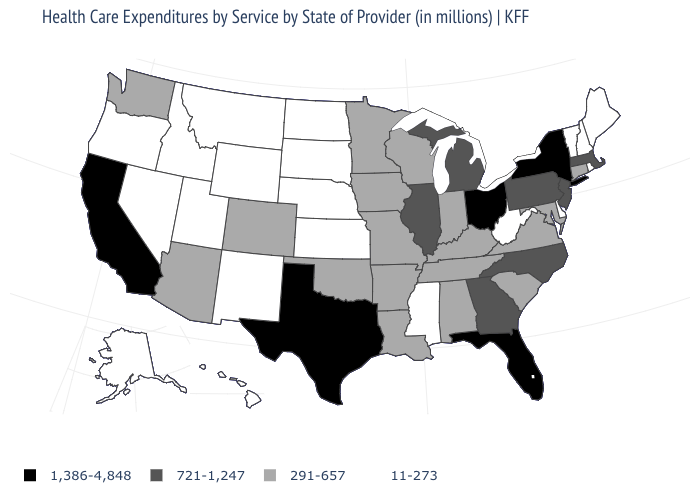What is the value of South Carolina?
Quick response, please. 291-657. Name the states that have a value in the range 721-1,247?
Write a very short answer. Georgia, Illinois, Massachusetts, Michigan, New Jersey, North Carolina, Pennsylvania. What is the value of California?
Write a very short answer. 1,386-4,848. What is the value of Ohio?
Concise answer only. 1,386-4,848. Does Florida have the highest value in the South?
Give a very brief answer. Yes. What is the value of New Jersey?
Be succinct. 721-1,247. What is the value of North Dakota?
Concise answer only. 11-273. Does California have the highest value in the West?
Short answer required. Yes. Does New York have the highest value in the Northeast?
Give a very brief answer. Yes. What is the value of Rhode Island?
Quick response, please. 11-273. Among the states that border Nevada , which have the highest value?
Concise answer only. California. Which states have the lowest value in the West?
Quick response, please. Alaska, Hawaii, Idaho, Montana, Nevada, New Mexico, Oregon, Utah, Wyoming. What is the highest value in states that border Washington?
Be succinct. 11-273. What is the highest value in states that border South Carolina?
Short answer required. 721-1,247. What is the highest value in the USA?
Short answer required. 1,386-4,848. 